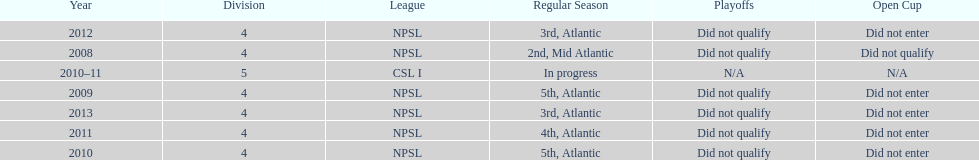What is the lowest place they came in 5th. 